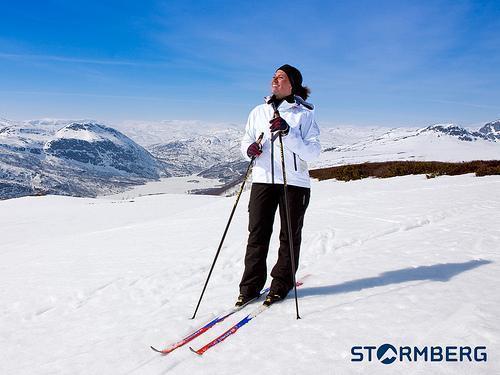How many of these bottles have yellow on the lid?
Give a very brief answer. 0. 